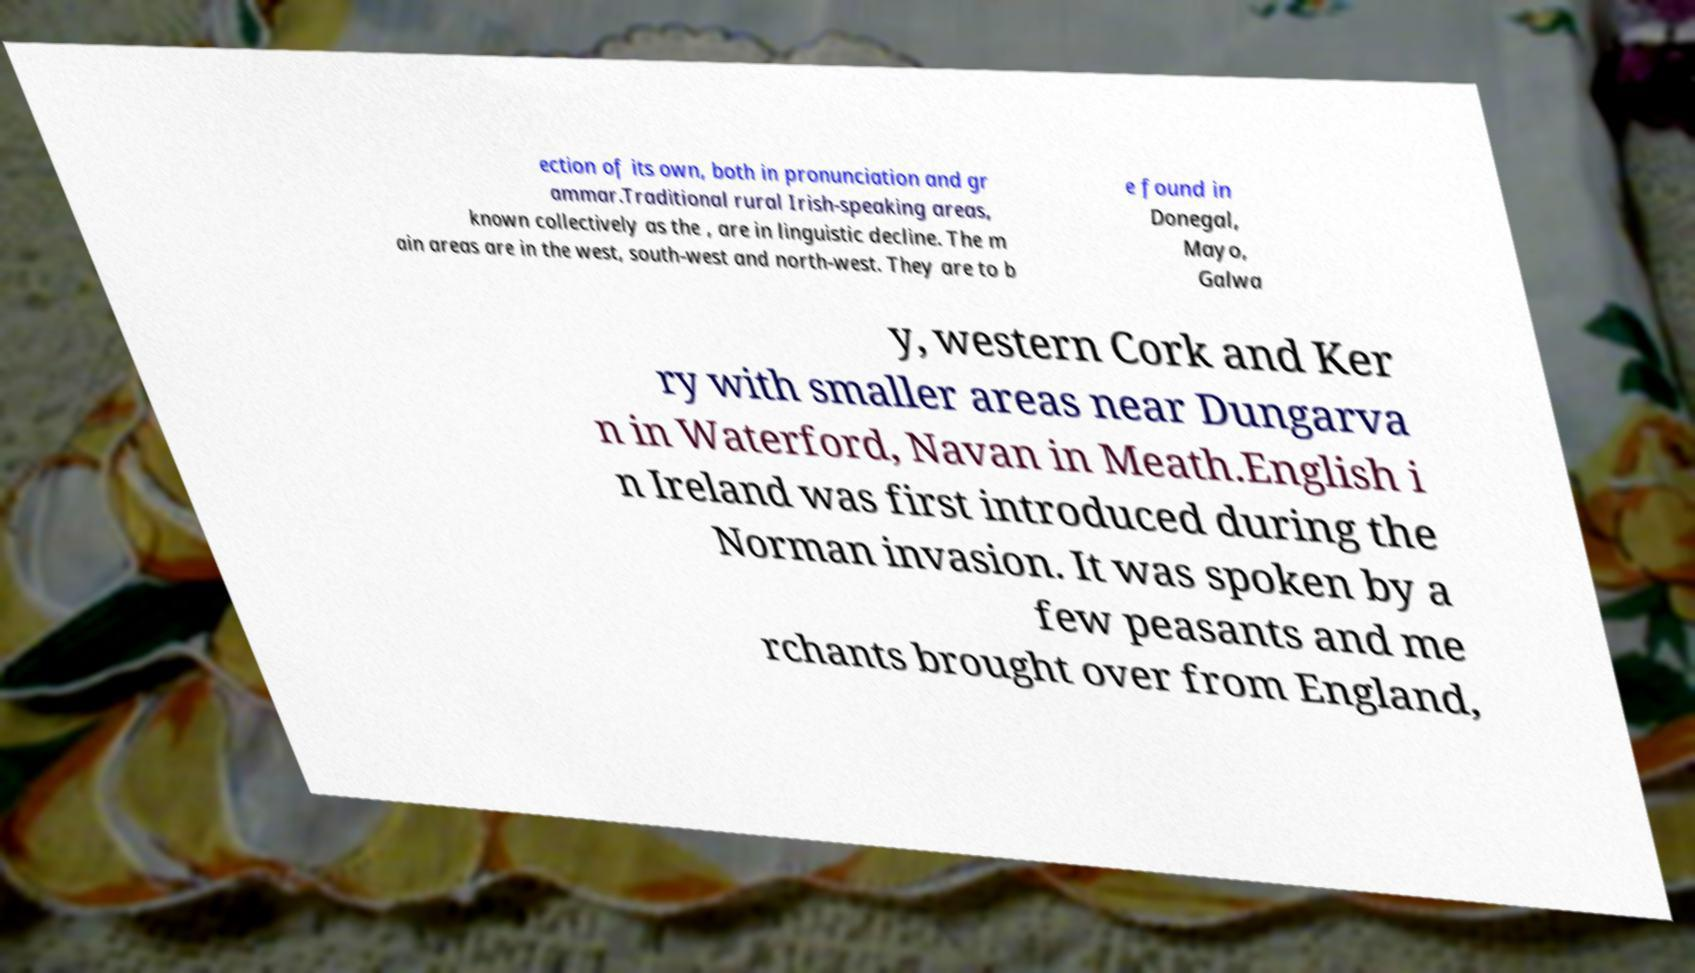What messages or text are displayed in this image? I need them in a readable, typed format. ection of its own, both in pronunciation and gr ammar.Traditional rural Irish-speaking areas, known collectively as the , are in linguistic decline. The m ain areas are in the west, south-west and north-west. They are to b e found in Donegal, Mayo, Galwa y, western Cork and Ker ry with smaller areas near Dungarva n in Waterford, Navan in Meath.English i n Ireland was first introduced during the Norman invasion. It was spoken by a few peasants and me rchants brought over from England, 